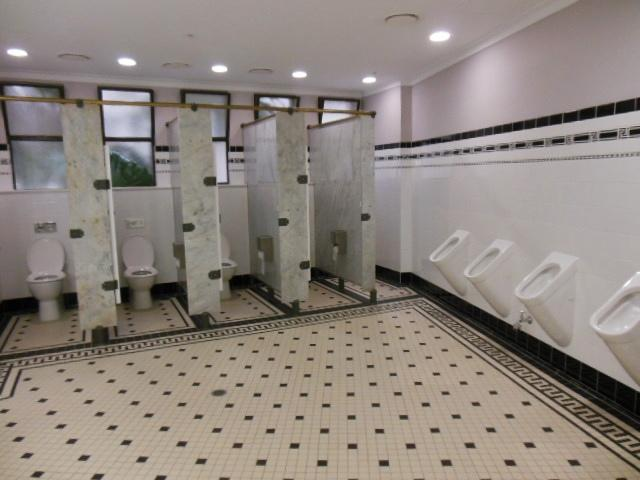What type of location is this? Please explain your reasoning. public. There are several stalls and urinals 